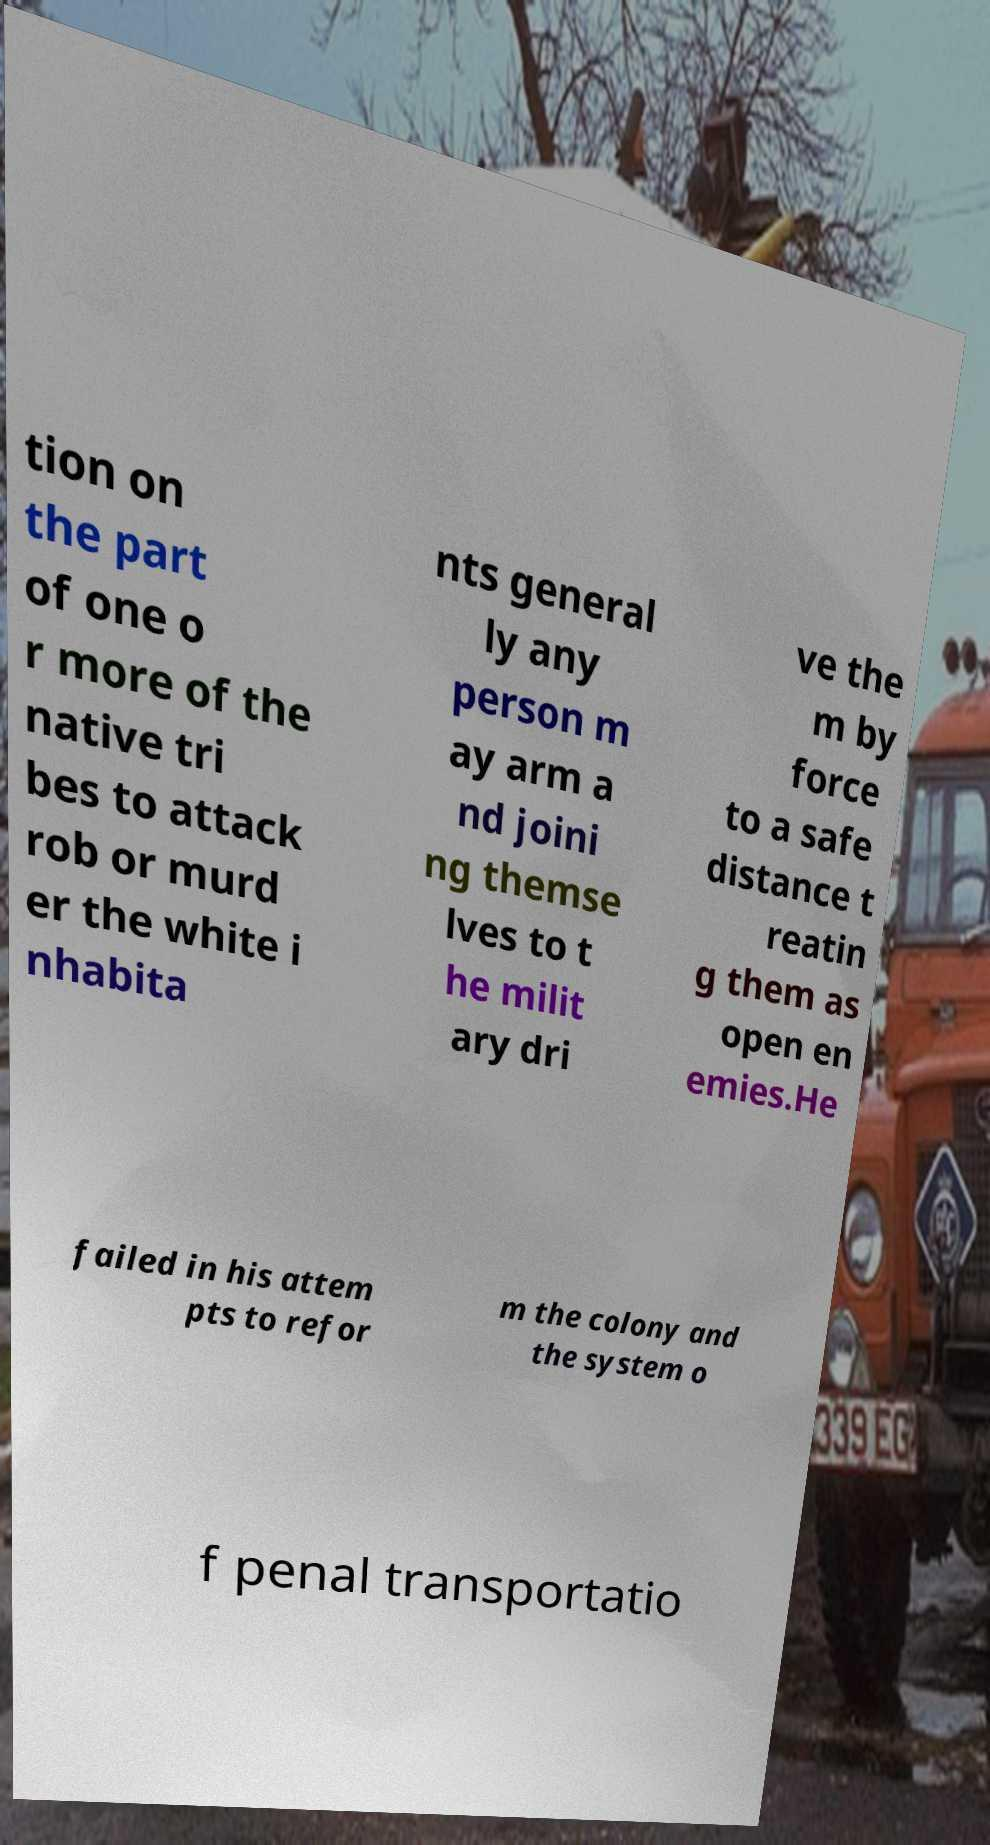Could you extract and type out the text from this image? tion on the part of one o r more of the native tri bes to attack rob or murd er the white i nhabita nts general ly any person m ay arm a nd joini ng themse lves to t he milit ary dri ve the m by force to a safe distance t reatin g them as open en emies.He failed in his attem pts to refor m the colony and the system o f penal transportatio 